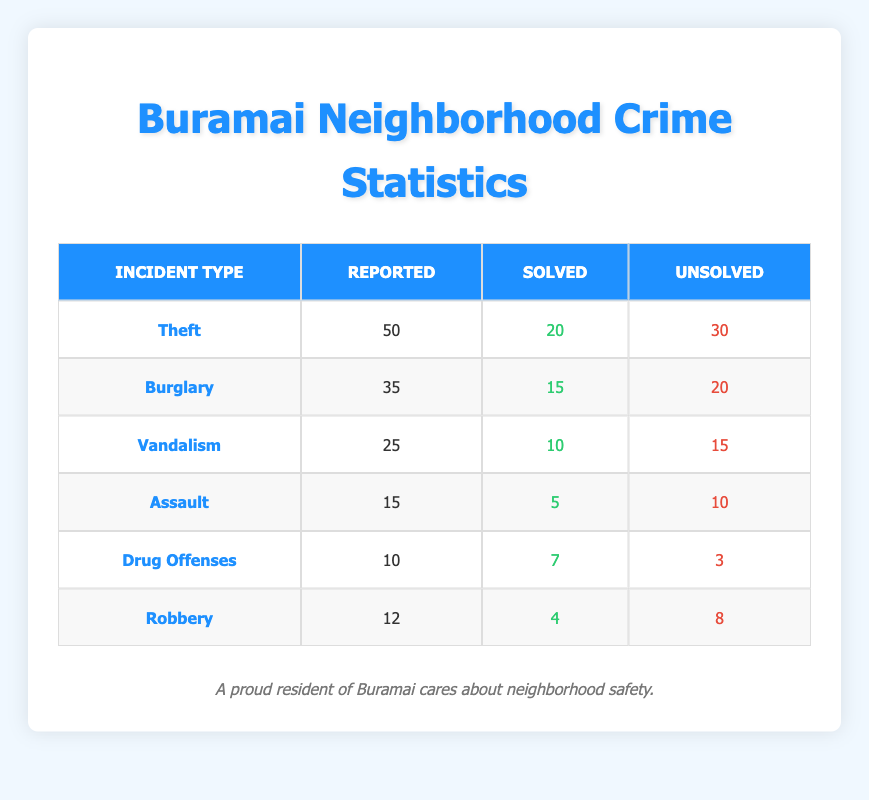What is the total number of reported incidents across all types? To find the total reported incidents, we need to sum the 'reported' values from each incident type: 50 (Theft) + 35 (Burglary) + 25 (Vandalism) + 15 (Assault) + 10 (Drug Offenses) + 12 (Robbery) = 147 reported incidents.
Answer: 147 What is the difference between the number of unsolved Theft and unsolved Burglary incidents? We take the unsolved counts: 30 (Theft) - 20 (Burglary) = 10. Therefore, there are 10 more unsolved Theft incidents than unsolved Burglary incidents.
Answer: 10 Is the number of solved Assault cases greater than the number of solved Drug Offenses cases? Solved Assault: 5 and Solved Drug Offenses: 7. Since 5 is less than 7, the statement is false.
Answer: No What percentage of reported incidents for Vandalism were solved? We take the solved Vandalism cases (10) divided by reported Vandalism cases (25) and multiply by 100 to convert to percent: (10/25) * 100 = 40%. Thus, 40% of reported Vandalism incidents were solved.
Answer: 40% Which incident type has the highest number of reported cases? Comparing the reported values: Theft (50), Burglary (35), Vandalism (25), Assault (15), Drug Offenses (10), and Robbery (12), it's evident that Theft has the highest at 50 reported cases.
Answer: Theft What is the total number of unsolved incidents for all types? To find the total unsolved incidents, we sum the 'unsolved' values: 30 (Theft) + 20 (Burglary) + 15 (Vandalism) + 10 (Assault) + 3 (Drug Offenses) + 8 (Robbery) = 86 unsolved incidents.
Answer: 86 Are there more solved Drug Offenses cases than solved Robbery cases? Solved Drug Offenses: 7, Solved Robbery: 4. Since 7 is greater than 4, the statement is true.
Answer: Yes What is the ratio of solved Theft cases to reported Theft cases? The ratio is calculated by taking solved Theft cases (20) divided by reported Theft cases (50), giving 20:50, which simplifies to 2:5.
Answer: 2:5 Which incident type has the highest rate of unsolved cases as a percentage of reported cases? To find this, calculate the unsolved rate for each type: Theft (60%), Burglary (57.14%), Vandalism (60%), Assault (66.67%), Drug Offenses (30%), Robbery (66.67%). Assault has the highest unsolved rate at 66.67%.
Answer: Assault 